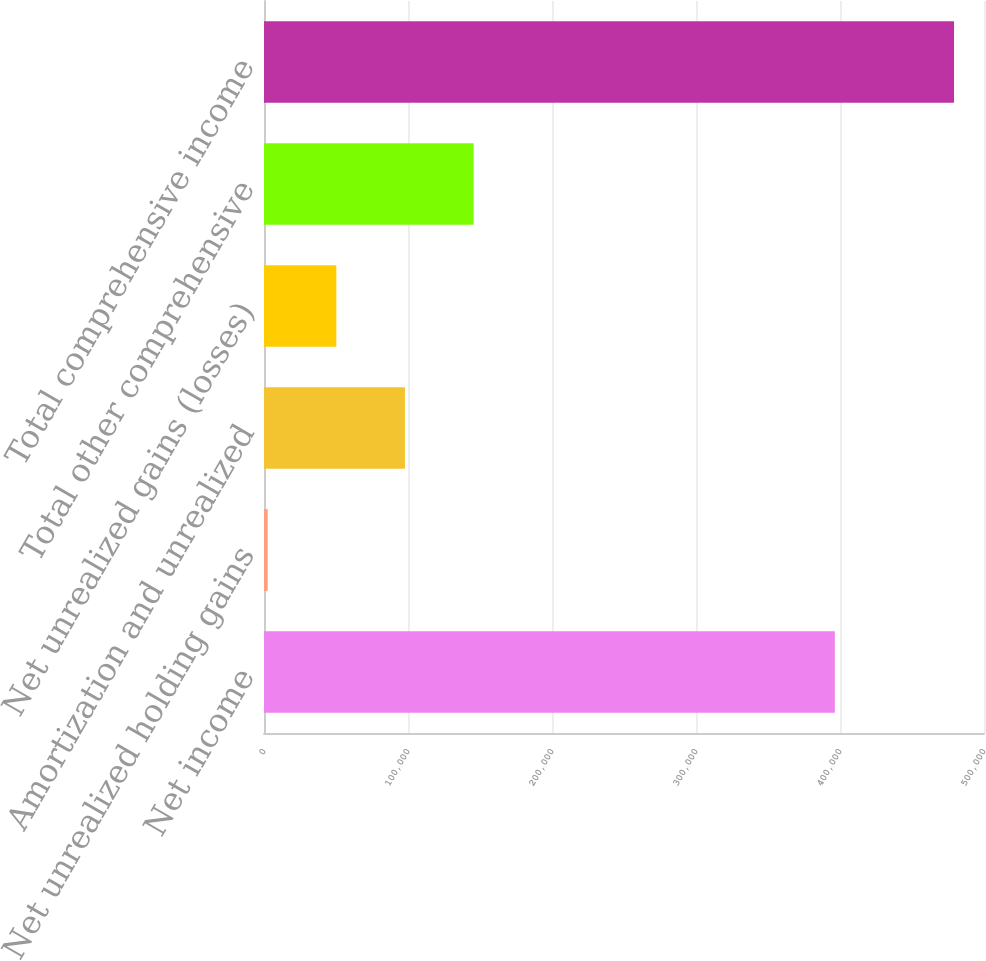<chart> <loc_0><loc_0><loc_500><loc_500><bar_chart><fcel>Net income<fcel>Net unrealized holding gains<fcel>Amortization and unrealized<fcel>Net unrealized gains (losses)<fcel>Total other comprehensive<fcel>Total comprehensive income<nl><fcel>396421<fcel>2564<fcel>97889<fcel>50226.5<fcel>145552<fcel>479189<nl></chart> 